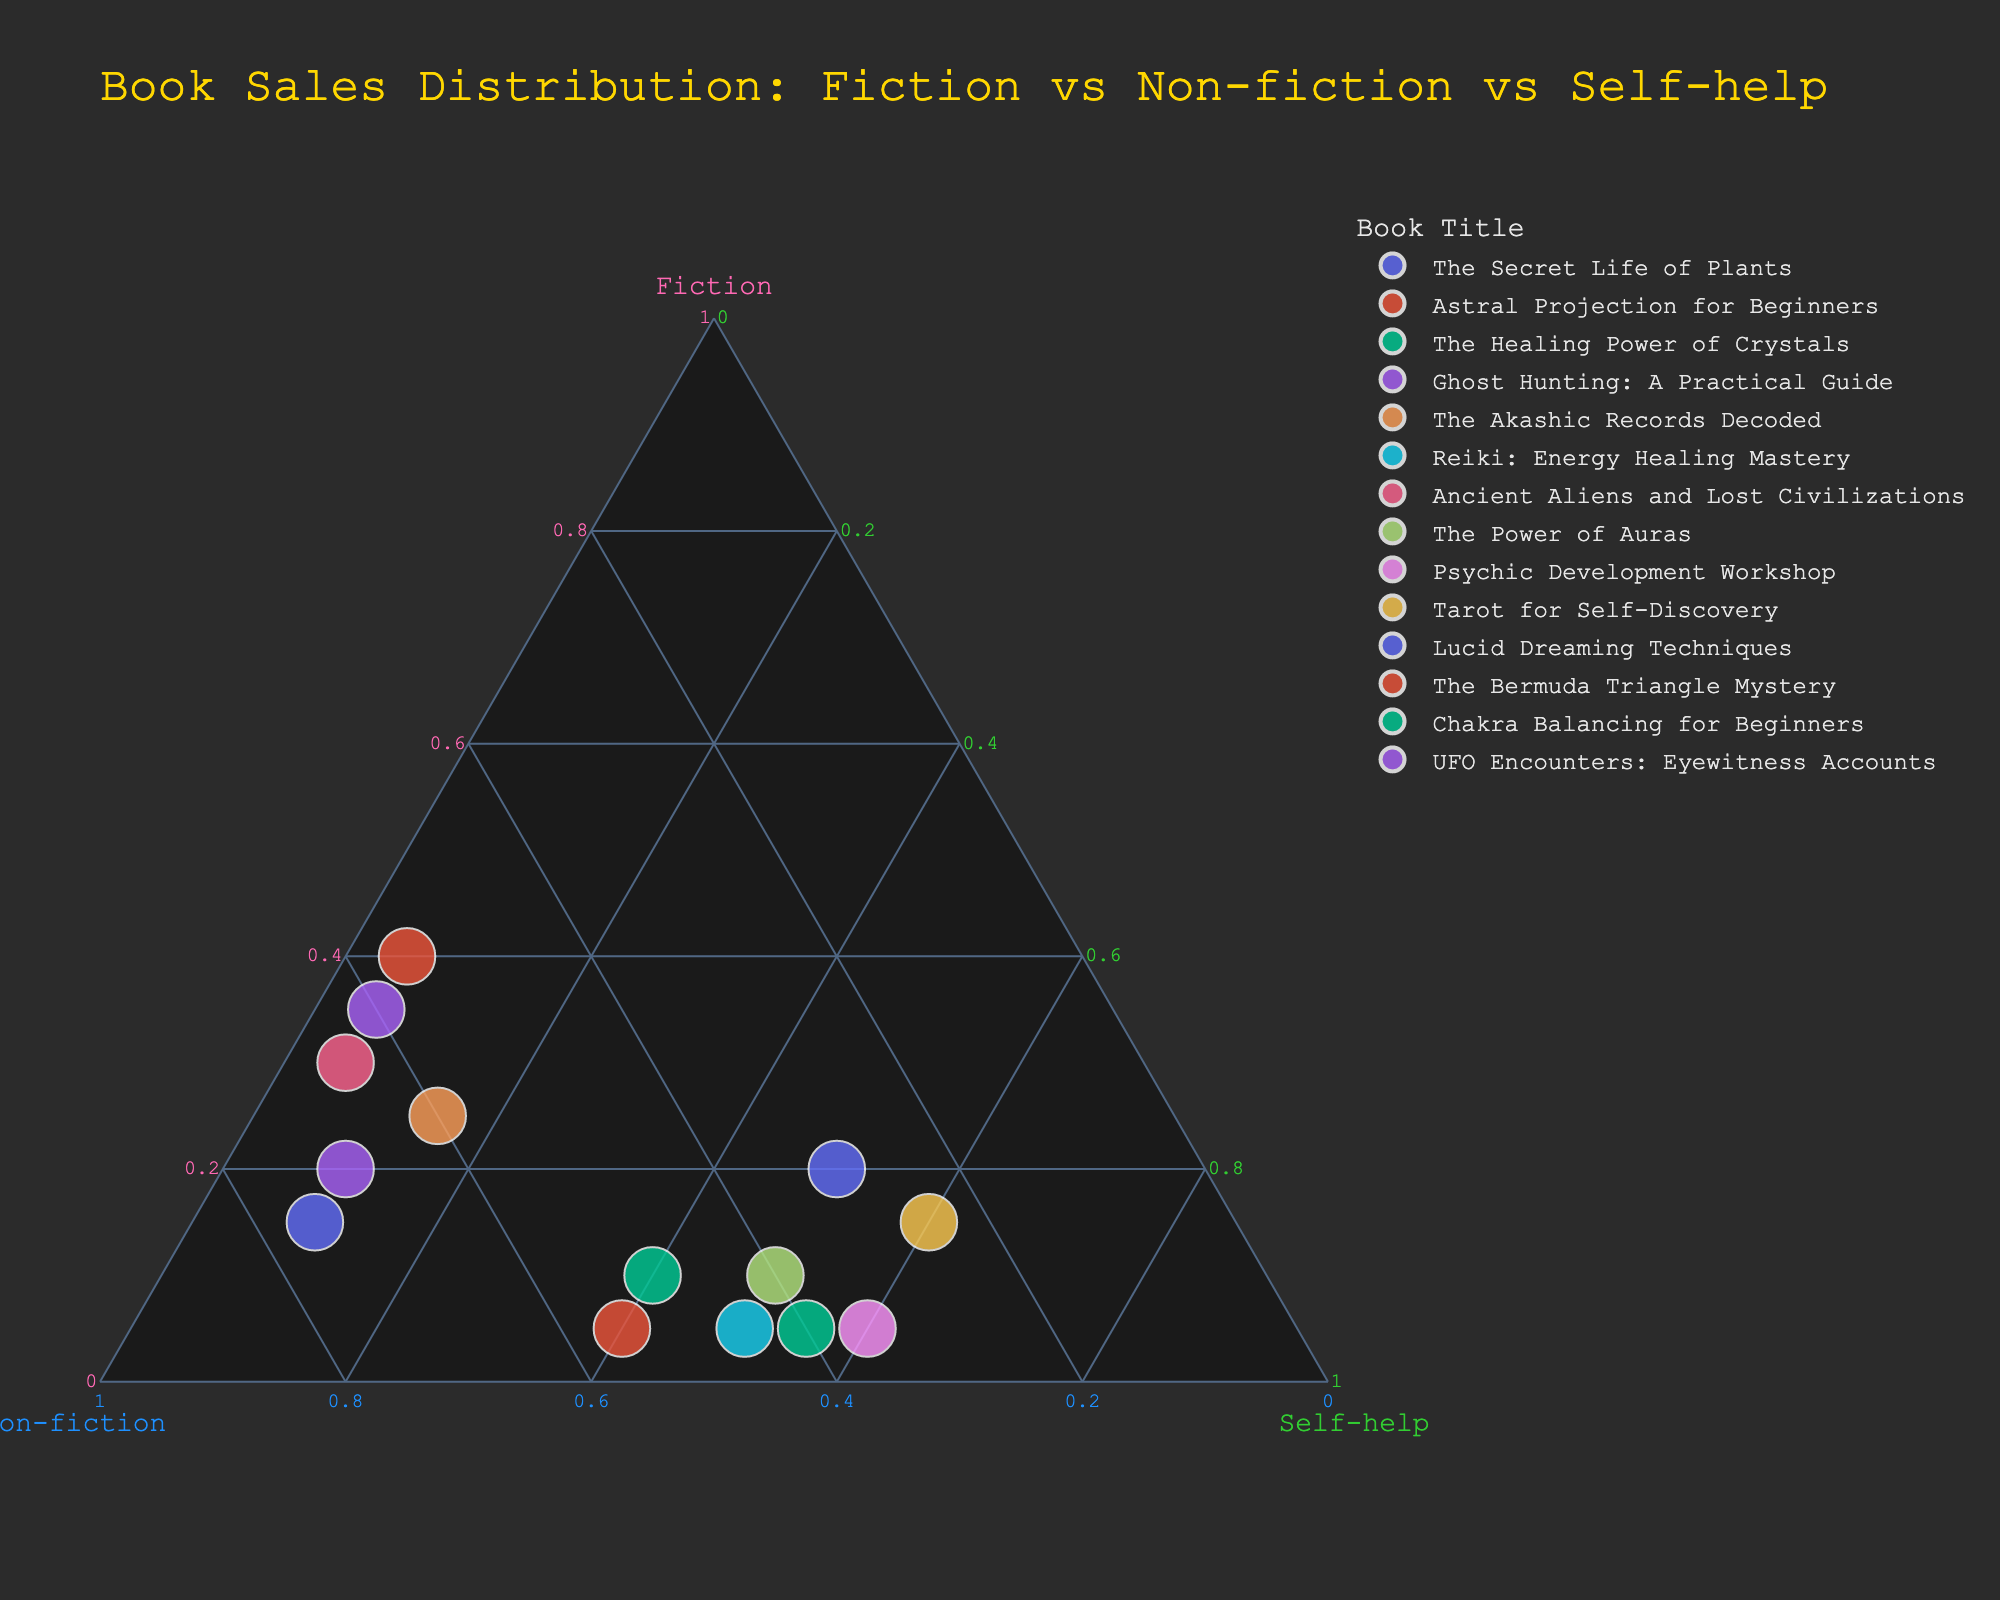What is the title of the plot? The title is displayed at the top of the plot and is typically larger in font size and distinguished by a different color for visualization purposes.
Answer: Book Sales Distribution: Fiction vs Non-fiction vs Self-help What book title has the highest proportion of fiction? The highest proportion in the fiction axis means it will be closest to the fiction vertex which is colored differently. "The Bermuda Triangle Mystery" is closest to that vertex.
Answer: The Bermuda Triangle Mystery Which books have a higher proportion of self-help than non-fiction? By looking at the placement toward the self-help axis, books further from the non-fiction axis compared to the self-help axis fit this description. "Psychic Development Workshop", "Tarot for Self-Discovery", "Chakra Balancing for Beginners" are such examples.
Answer: Psychic Development Workshop, Tarot for Self-Discovery, Chakra Balancing for Beginners What is the relative size of "Lucid Dreaming Techniques" in the plot? The size is represented by the geographical size of the point within the plot, which scales with the summation metric; it is one of the medium-sized points on the plot.
Answer: Medium-sized Which category has the highest proportion for the book "Reiki: Energy Healing Mastery"? Locate the "Reiki: Energy Healing Mastery" on the plot and see towards which vertex it is the closest.
Answer: Self-help Which book has the lowest proportion in fiction? Find the point farthest from the fiction vertex. "Reiki: Energy Healing Mastery" and "Chakra Balancing for Beginners" are candidates here.
Answer: Reiki: Energy Healing Mastery, Chakra Balancing for Beginners Are there any books with a balanced proportion across all three categories? Check if there is any point located near the center of the ternary plot; balanced proportions result in an equidistant position from all three vertices. The points are not exactly centered but "The Akashic Records Decoded" is one of those closer to the middle.
Answer: The Akashic Records Decoded How many books have a non-fiction proportion greater than 0.5? Identify the points positioned in the region closer to the non-fiction vertex, representing greater than 0.5. The count includes The Secret Life of Plants, Astral Projection for Beginners, Ghost Hunting: A Practical Guide, The Akashic Records Decoded, Ancient Aliens and Lost Civilizations, The Bermuda Triangle Mystery, UFO Encounters: Eyewitness Accounts.
Answer: 7 Which book has the smallest size in the plot? The size is indicated by the dimension of the point; the smallest point will be the least visually significant one. The size attribute here is multiplied by a proportional factor based on the cumulative proportion result which might infer smaller actual offsets.
Answer: Astral Projection for Beginners What is the relationship between "The Secret Life of Plants" and "The Bermuda Triangle Mystery" in terms of non-fiction proportion? Compare both points' distances from the non-fiction vertex. "The Bermuda Triangle Mystery" has a slightly lower distance when compared visually.
Answer: The Secret Life of Plants has a higher non-fiction proportion than The Bermuda Triangle Mystery 